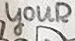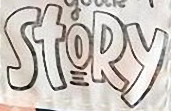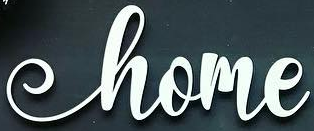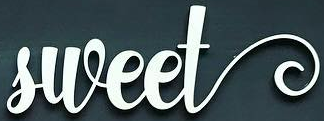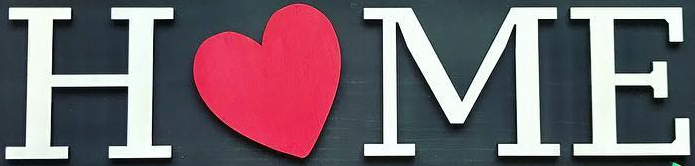What text appears in these images from left to right, separated by a semicolon? youR; StoRy; home; sweet; HOME 